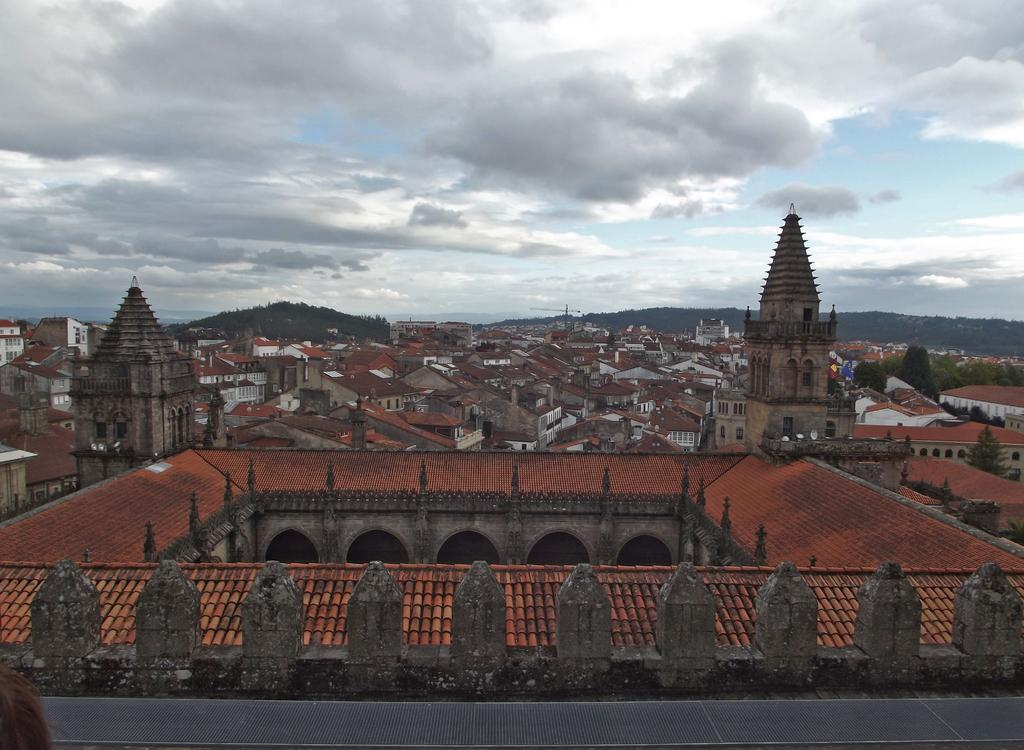What type of structures are present in the image? There are buildings with roofs in the image. What natural features can be seen in the image? There are mountains visible in the image. What is the color of the sky in the background? The sky is blue in the background. Are there any weather elements visible in the sky? Yes, there are clouds in the sky in the background. What type of cub is playing with a toy in the bedroom in the image? There is no cub or bedroom present in the image; it features buildings, mountains, and a blue sky with clouds. What type of skin condition is visible on the people in the image? There are no people present in the image, so it is not possible to determine if any skin conditions are visible. 